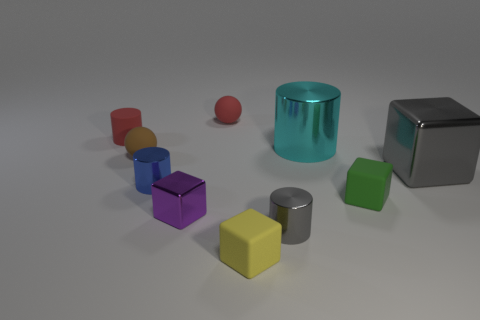Subtract all cubes. How many objects are left? 6 Add 2 large cylinders. How many large cylinders are left? 3 Add 7 green cubes. How many green cubes exist? 8 Subtract 0 gray spheres. How many objects are left? 10 Subtract all blocks. Subtract all yellow metal balls. How many objects are left? 6 